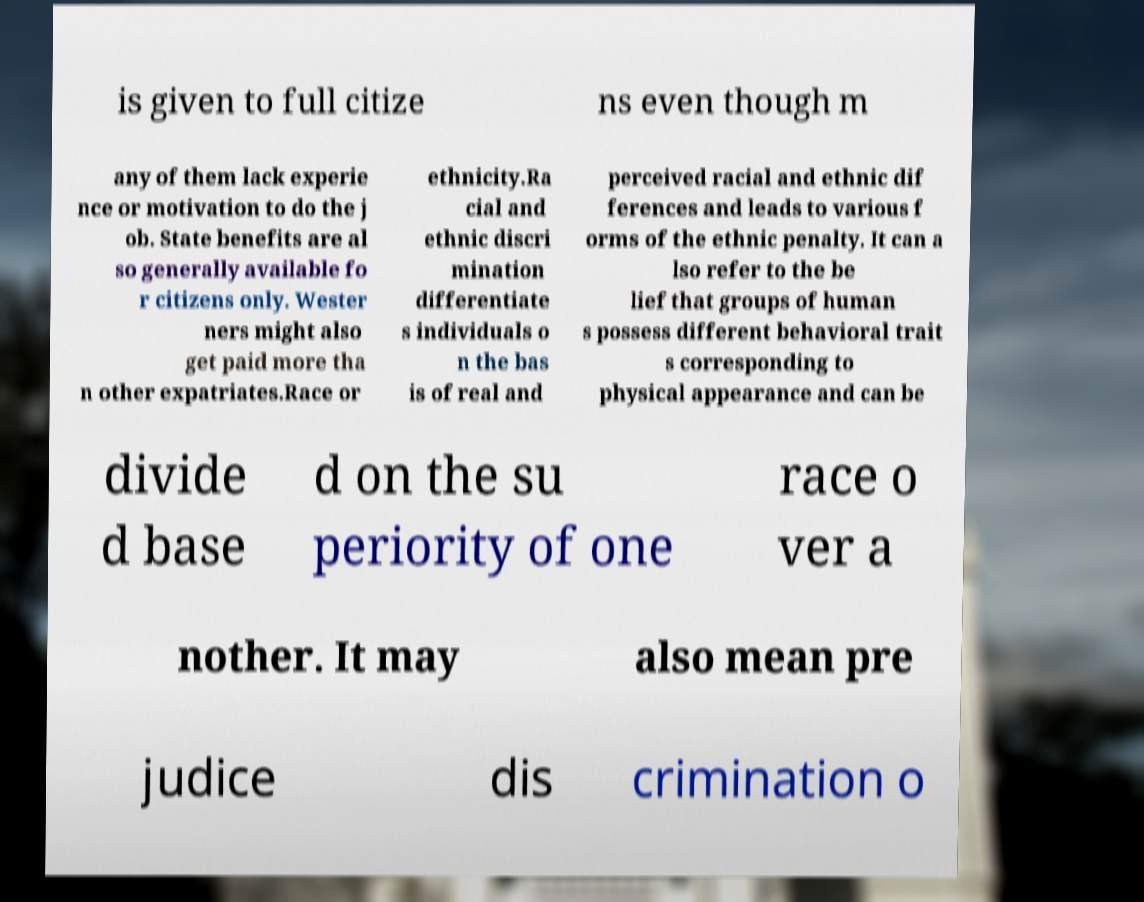There's text embedded in this image that I need extracted. Can you transcribe it verbatim? is given to full citize ns even though m any of them lack experie nce or motivation to do the j ob. State benefits are al so generally available fo r citizens only. Wester ners might also get paid more tha n other expatriates.Race or ethnicity.Ra cial and ethnic discri mination differentiate s individuals o n the bas is of real and perceived racial and ethnic dif ferences and leads to various f orms of the ethnic penalty. It can a lso refer to the be lief that groups of human s possess different behavioral trait s corresponding to physical appearance and can be divide d base d on the su periority of one race o ver a nother. It may also mean pre judice dis crimination o 